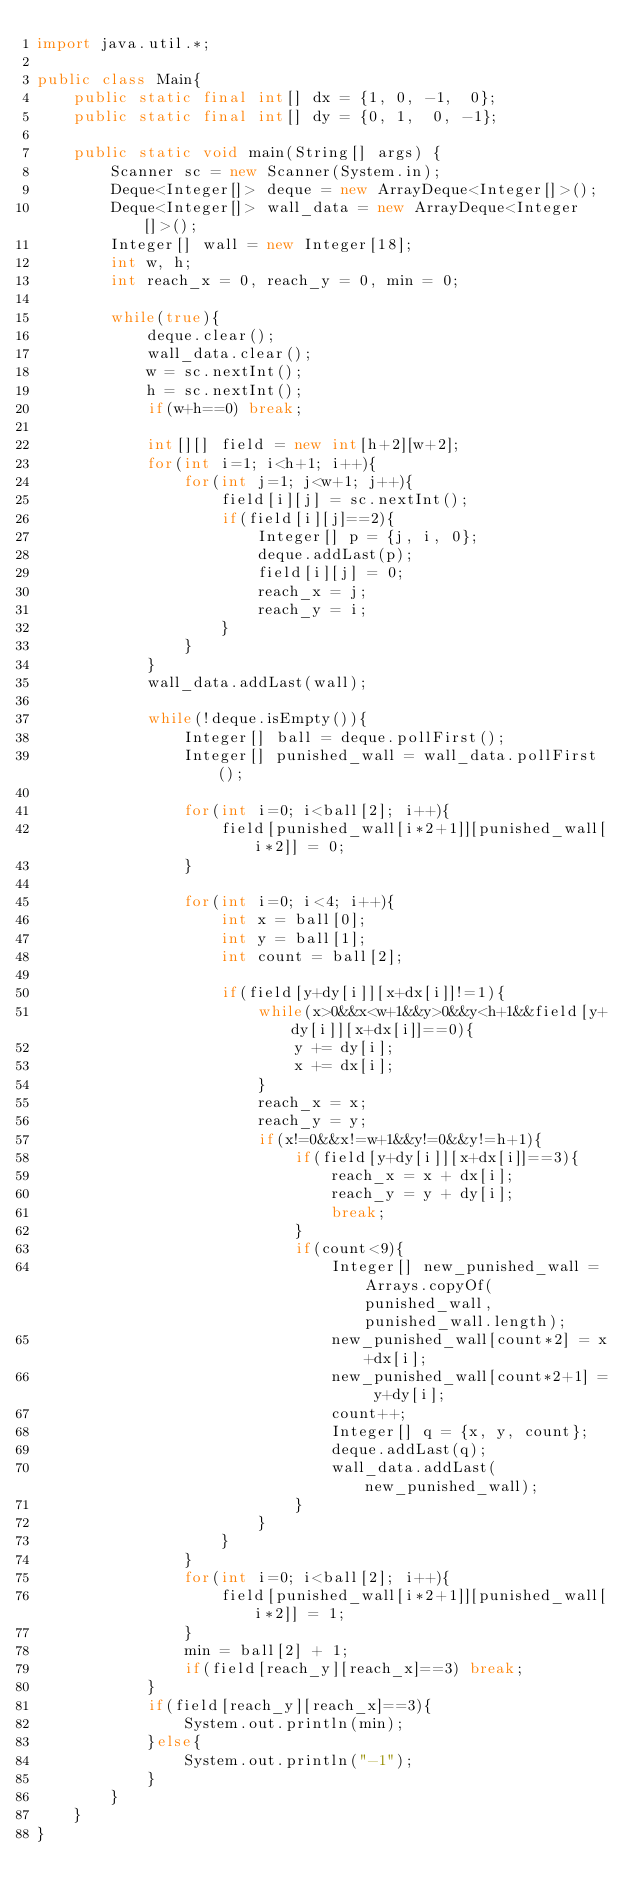<code> <loc_0><loc_0><loc_500><loc_500><_Java_>import java.util.*;

public class Main{
	public static final int[] dx = {1, 0, -1,  0};
	public static final int[] dy = {0, 1,  0, -1};

	public static void main(String[] args) {
		Scanner sc = new Scanner(System.in);
		Deque<Integer[]> deque = new ArrayDeque<Integer[]>();
		Deque<Integer[]> wall_data = new ArrayDeque<Integer[]>();
		Integer[] wall = new Integer[18];
		int w, h;
		int reach_x = 0, reach_y = 0, min = 0;

		while(true){
			deque.clear();
			wall_data.clear();
			w = sc.nextInt();
			h = sc.nextInt();
			if(w+h==0) break;

			int[][] field = new int[h+2][w+2];
			for(int i=1; i<h+1; i++){
				for(int j=1; j<w+1; j++){
					field[i][j] = sc.nextInt();
					if(field[i][j]==2){
						Integer[] p = {j, i, 0};
						deque.addLast(p);
						field[i][j] = 0;
						reach_x = j;
						reach_y = i;
					}
				}
			}
			wall_data.addLast(wall);

			while(!deque.isEmpty()){
				Integer[] ball = deque.pollFirst();
				Integer[] punished_wall = wall_data.pollFirst();

				for(int i=0; i<ball[2]; i++){
					field[punished_wall[i*2+1]][punished_wall[i*2]] = 0;
				}

				for(int i=0; i<4; i++){
					int x = ball[0];
					int y = ball[1];
					int count = ball[2];

					if(field[y+dy[i]][x+dx[i]]!=1){
						while(x>0&&x<w+1&&y>0&&y<h+1&&field[y+dy[i]][x+dx[i]]==0){
							y += dy[i];
							x += dx[i];
						}
						reach_x = x;
						reach_y = y;
						if(x!=0&&x!=w+1&&y!=0&&y!=h+1){
							if(field[y+dy[i]][x+dx[i]]==3){
								reach_x = x + dx[i];
								reach_y = y + dy[i];
								break;
							}
							if(count<9){
								Integer[] new_punished_wall = Arrays.copyOf(punished_wall, punished_wall.length);
								new_punished_wall[count*2] = x+dx[i];
								new_punished_wall[count*2+1] = y+dy[i];
								count++;
								Integer[] q = {x, y, count};
								deque.addLast(q);
								wall_data.addLast(new_punished_wall);
							}
						}
					}
				}
				for(int i=0; i<ball[2]; i++){
					field[punished_wall[i*2+1]][punished_wall[i*2]] = 1;
				}
				min = ball[2] + 1;
				if(field[reach_y][reach_x]==3) break;
			}
			if(field[reach_y][reach_x]==3){
				System.out.println(min);
			}else{
				System.out.println("-1");
			}
		}
	}
}</code> 